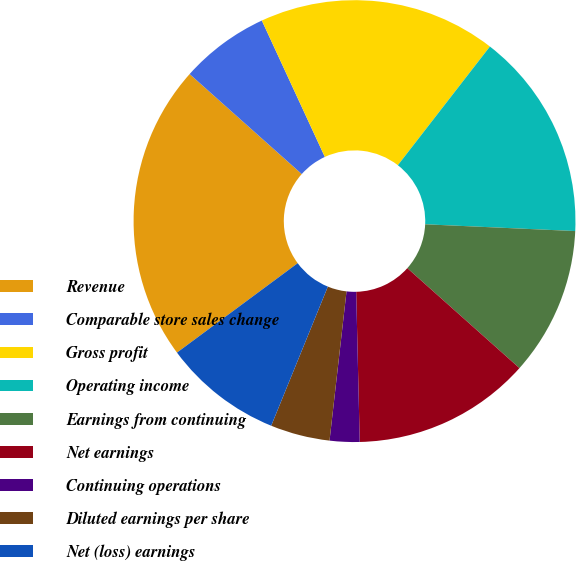Convert chart to OTSL. <chart><loc_0><loc_0><loc_500><loc_500><pie_chart><fcel>Revenue<fcel>Comparable store sales change<fcel>Gross profit<fcel>Operating income<fcel>Earnings from continuing<fcel>Net earnings<fcel>Continuing operations<fcel>Diluted earnings per share<fcel>Net (loss) earnings<fcel>Diluted (loss) earnings per<nl><fcel>21.74%<fcel>6.52%<fcel>17.39%<fcel>15.22%<fcel>10.87%<fcel>13.04%<fcel>2.18%<fcel>4.35%<fcel>8.7%<fcel>0.0%<nl></chart> 